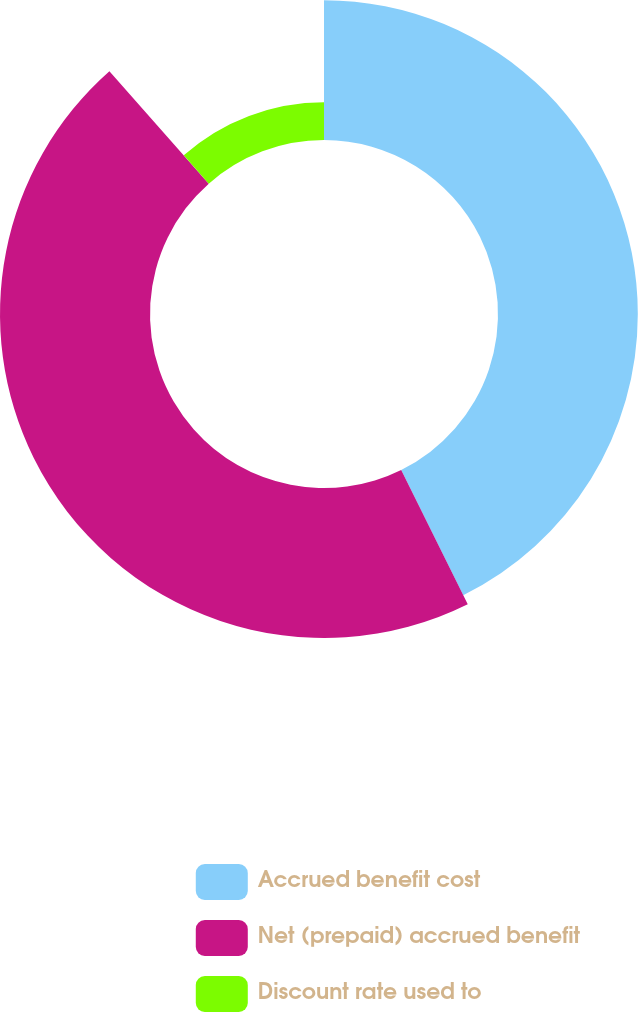Convert chart. <chart><loc_0><loc_0><loc_500><loc_500><pie_chart><fcel>Accrued benefit cost<fcel>Net (prepaid) accrued benefit<fcel>Discount rate used to<nl><fcel>42.68%<fcel>45.79%<fcel>11.52%<nl></chart> 